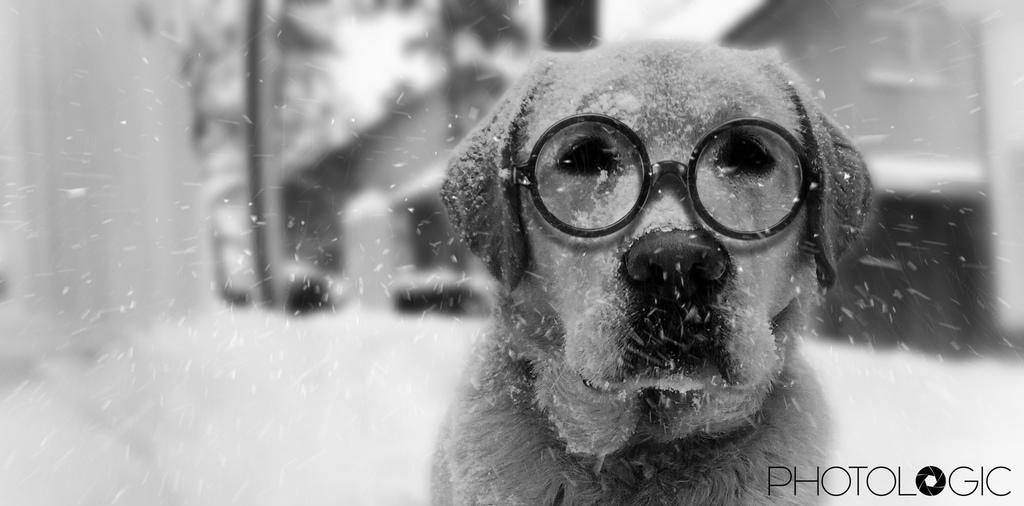What type of animal is present in the image? There is a dog in the image. What is unique about the dog's appearance? The dog is wearing spectacles. Is there any text present in the image? Yes, there is text in the bottom right corner of the image. How would you describe the background of the image? The background of the image is blurred. What type of muscle can be seen flexing in the image? There is no muscle visible in the image; it features a dog wearing spectacles. What sound does the dog make in the image? The image is static, so no sound can be heard. 